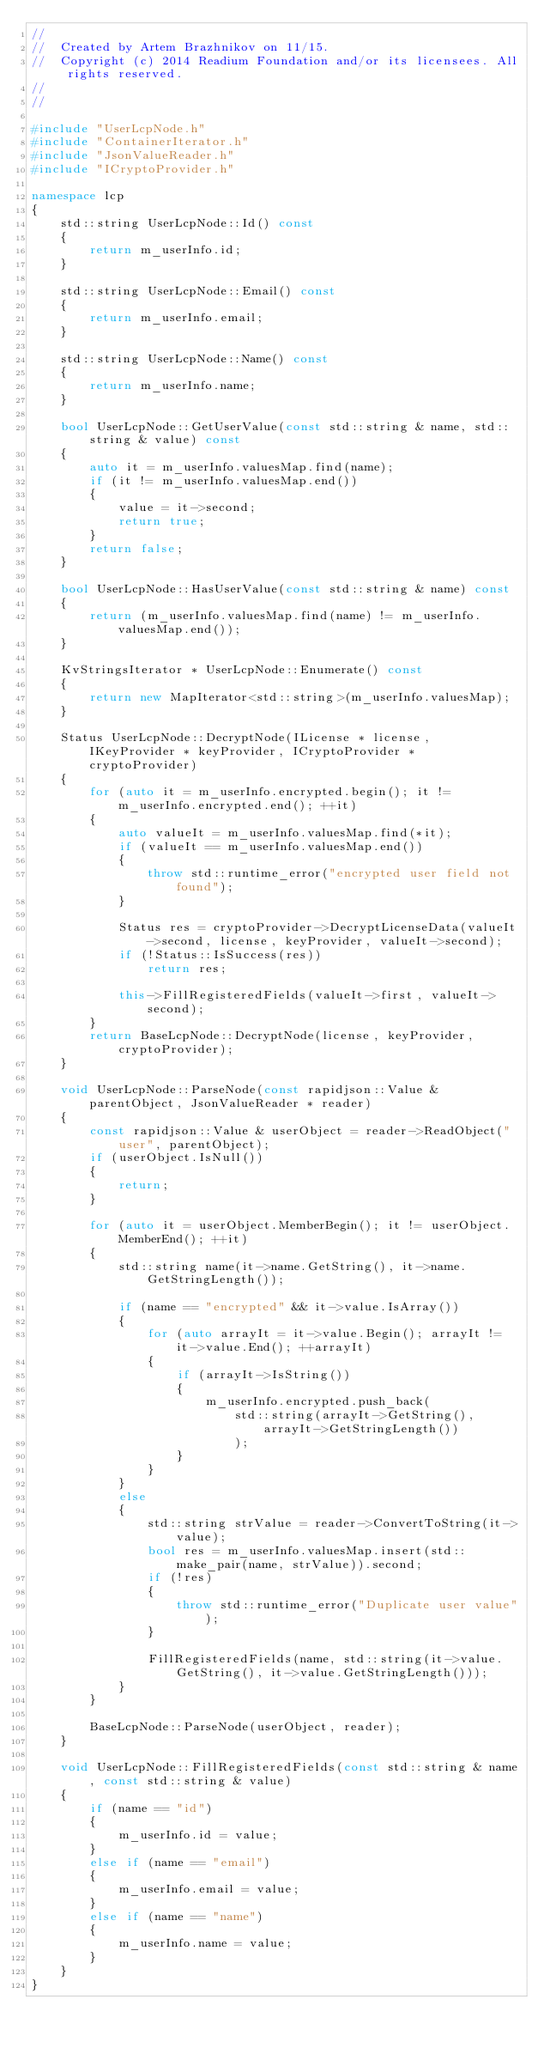<code> <loc_0><loc_0><loc_500><loc_500><_C++_>//
//  Created by Artem Brazhnikov on 11/15.
//  Copyright (c) 2014 Readium Foundation and/or its licensees. All rights reserved.
//
//

#include "UserLcpNode.h"
#include "ContainerIterator.h"
#include "JsonValueReader.h"
#include "ICryptoProvider.h"

namespace lcp
{
    std::string UserLcpNode::Id() const
    {
        return m_userInfo.id;
    }

    std::string UserLcpNode::Email() const
    {
        return m_userInfo.email;
    }

    std::string UserLcpNode::Name() const
    {
        return m_userInfo.name;
    }

    bool UserLcpNode::GetUserValue(const std::string & name, std::string & value) const
    {
        auto it = m_userInfo.valuesMap.find(name);
        if (it != m_userInfo.valuesMap.end())
        {
            value = it->second;
            return true;
        }
        return false;
    }

    bool UserLcpNode::HasUserValue(const std::string & name) const
    {
        return (m_userInfo.valuesMap.find(name) != m_userInfo.valuesMap.end());
    }

    KvStringsIterator * UserLcpNode::Enumerate() const
    {
        return new MapIterator<std::string>(m_userInfo.valuesMap);
    }
    
    Status UserLcpNode::DecryptNode(ILicense * license, IKeyProvider * keyProvider, ICryptoProvider * cryptoProvider)
    {
        for (auto it = m_userInfo.encrypted.begin(); it != m_userInfo.encrypted.end(); ++it)
        {
            auto valueIt = m_userInfo.valuesMap.find(*it);
            if (valueIt == m_userInfo.valuesMap.end())
            {
                throw std::runtime_error("encrypted user field not found");
            }

            Status res = cryptoProvider->DecryptLicenseData(valueIt->second, license, keyProvider, valueIt->second);
            if (!Status::IsSuccess(res))
                return res;

            this->FillRegisteredFields(valueIt->first, valueIt->second);
        }
        return BaseLcpNode::DecryptNode(license, keyProvider, cryptoProvider);
    }

    void UserLcpNode::ParseNode(const rapidjson::Value & parentObject, JsonValueReader * reader)
    {
        const rapidjson::Value & userObject = reader->ReadObject("user", parentObject);
        if (userObject.IsNull())
        {
            return;
        }

        for (auto it = userObject.MemberBegin(); it != userObject.MemberEnd(); ++it)
        {
            std::string name(it->name.GetString(), it->name.GetStringLength());

            if (name == "encrypted" && it->value.IsArray())
            {
                for (auto arrayIt = it->value.Begin(); arrayIt != it->value.End(); ++arrayIt)
                {
                    if (arrayIt->IsString())
                    {
                        m_userInfo.encrypted.push_back(
                            std::string(arrayIt->GetString(), arrayIt->GetStringLength())
                            );
                    }
                }
            }
            else
            {
                std::string strValue = reader->ConvertToString(it->value);
                bool res = m_userInfo.valuesMap.insert(std::make_pair(name, strValue)).second;
                if (!res)
                {
                    throw std::runtime_error("Duplicate user value");
                }

                FillRegisteredFields(name, std::string(it->value.GetString(), it->value.GetStringLength()));
            }
        }

        BaseLcpNode::ParseNode(userObject, reader);
    }

    void UserLcpNode::FillRegisteredFields(const std::string & name, const std::string & value)
    {
        if (name == "id")
        {
            m_userInfo.id = value;
        }
        else if (name == "email")
        {
            m_userInfo.email = value;
        }
        else if (name == "name")
        {
            m_userInfo.name = value;
        }
    }
}</code> 